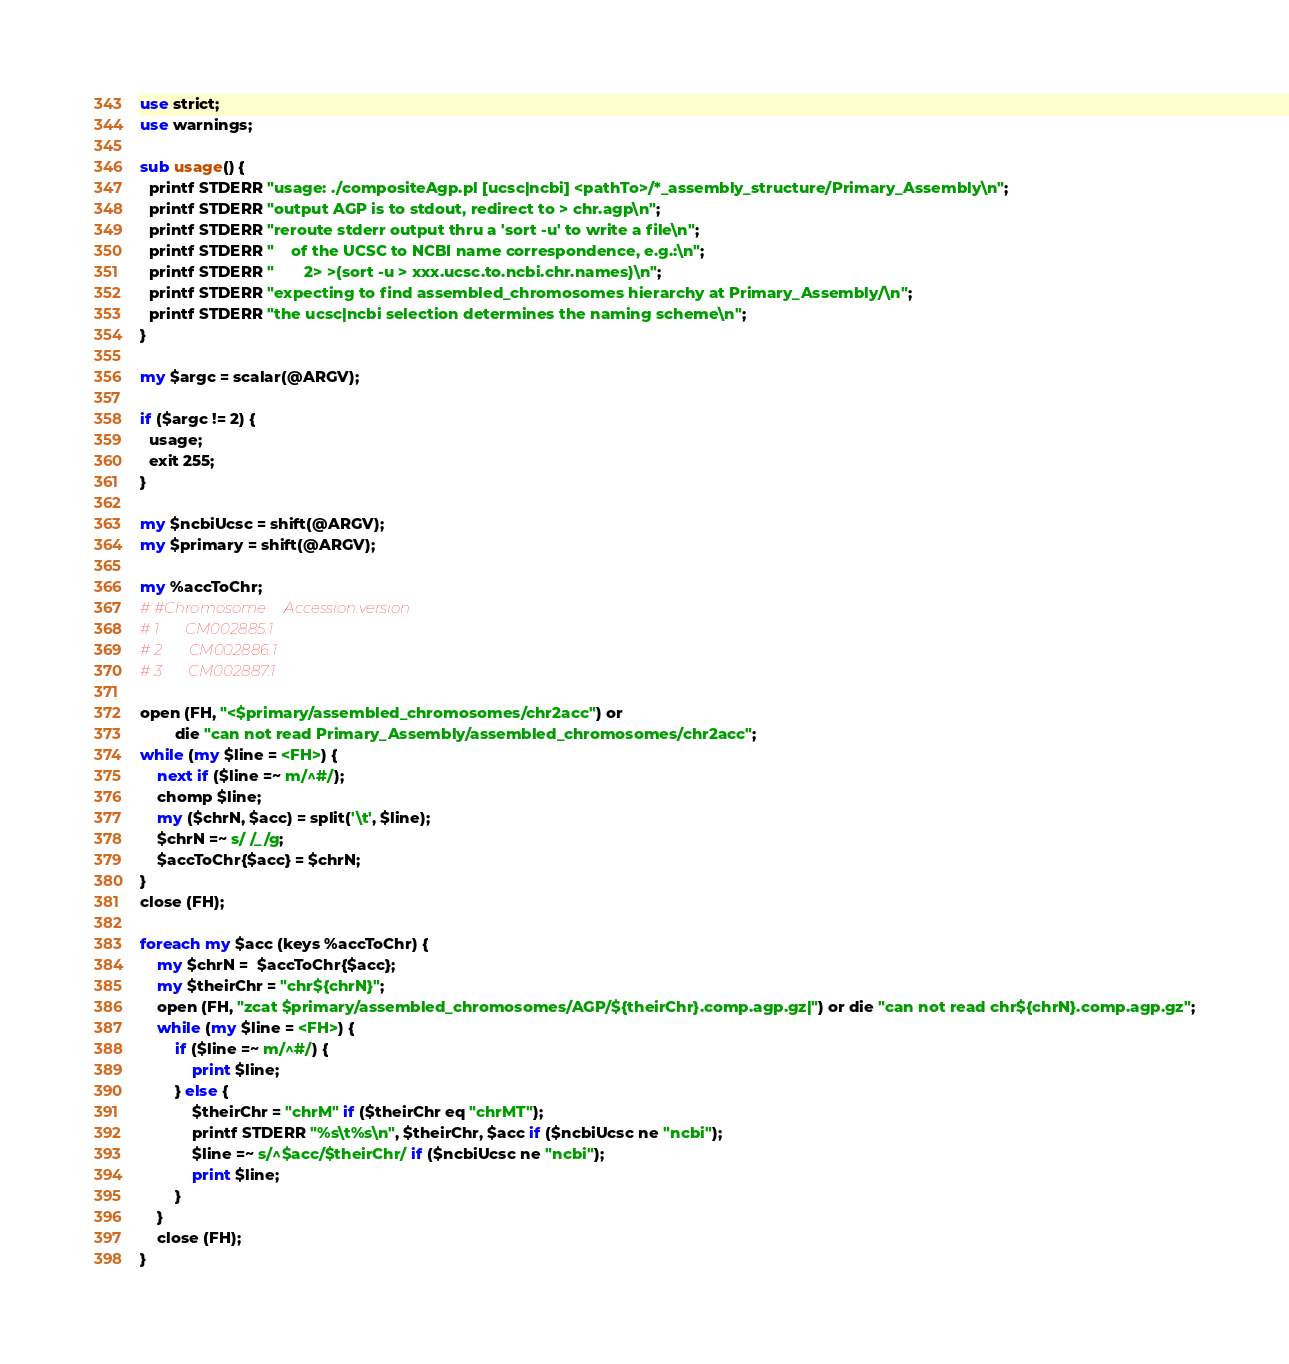<code> <loc_0><loc_0><loc_500><loc_500><_Perl_>
use strict;
use warnings;

sub usage() {
  printf STDERR "usage: ./compositeAgp.pl [ucsc|ncbi] <pathTo>/*_assembly_structure/Primary_Assembly\n";
  printf STDERR "output AGP is to stdout, redirect to > chr.agp\n";
  printf STDERR "reroute stderr output thru a 'sort -u' to write a file\n";
  printf STDERR "    of the UCSC to NCBI name correspondence, e.g.:\n";
  printf STDERR "       2> >(sort -u > xxx.ucsc.to.ncbi.chr.names)\n";
  printf STDERR "expecting to find assembled_chromosomes hierarchy at Primary_Assembly/\n";
  printf STDERR "the ucsc|ncbi selection determines the naming scheme\n";
}

my $argc = scalar(@ARGV);

if ($argc != 2) {
  usage;
  exit 255;
}

my $ncbiUcsc = shift(@ARGV);
my $primary = shift(@ARGV);

my %accToChr;
# #Chromosome     Accession.version
# 1       CM002885.1
# 2       CM002886.1
# 3       CM002887.1

open (FH, "<$primary/assembled_chromosomes/chr2acc") or
        die "can not read Primary_Assembly/assembled_chromosomes/chr2acc";
while (my $line = <FH>) {
    next if ($line =~ m/^#/);
    chomp $line;
    my ($chrN, $acc) = split('\t', $line);
    $chrN =~ s/ /_/g;
    $accToChr{$acc} = $chrN;
}
close (FH);

foreach my $acc (keys %accToChr) {
    my $chrN =  $accToChr{$acc};
    my $theirChr = "chr${chrN}";
    open (FH, "zcat $primary/assembled_chromosomes/AGP/${theirChr}.comp.agp.gz|") or die "can not read chr${chrN}.comp.agp.gz";
    while (my $line = <FH>) {
        if ($line =~ m/^#/) {
            print $line;
        } else {
            $theirChr = "chrM" if ($theirChr eq "chrMT");
            printf STDERR "%s\t%s\n", $theirChr, $acc if ($ncbiUcsc ne "ncbi");
            $line =~ s/^$acc/$theirChr/ if ($ncbiUcsc ne "ncbi");
            print $line;
        }
    }
    close (FH);
}
</code> 